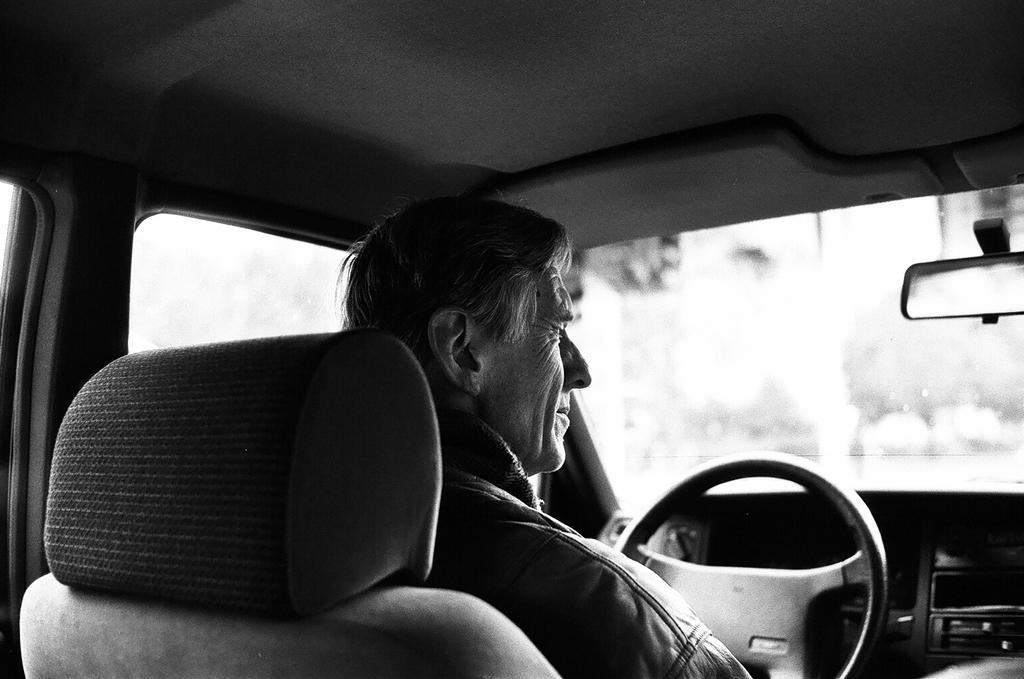Please provide a concise description of this image. Here we can see a man sitting on the car, and here is the steering. 